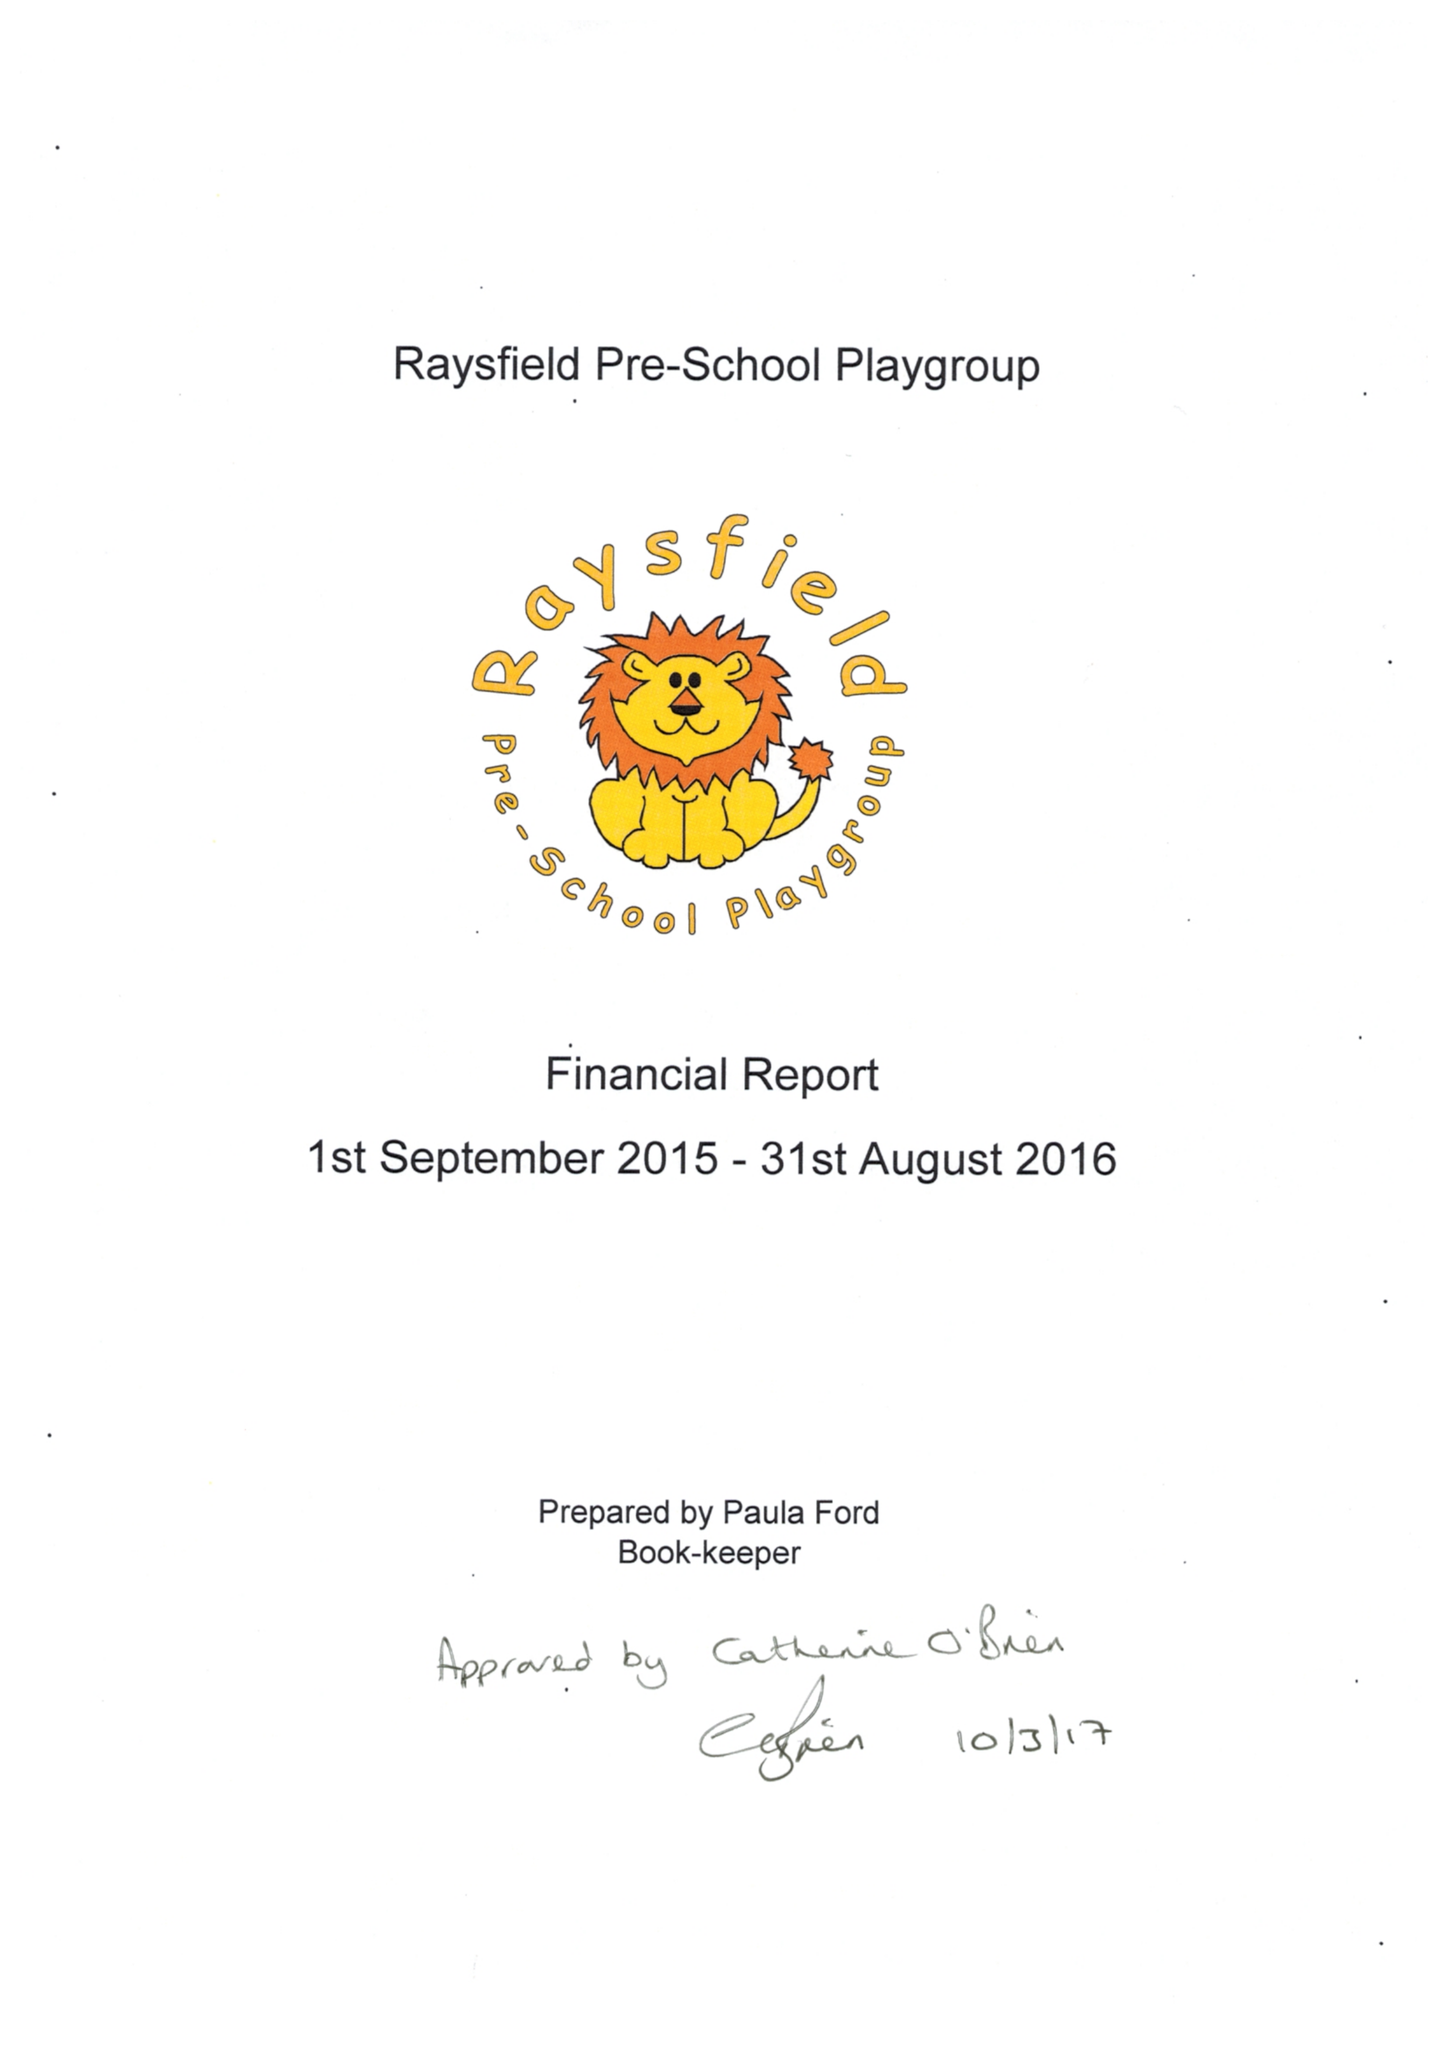What is the value for the charity_name?
Answer the question using a single word or phrase. Raysfield Pre - School 